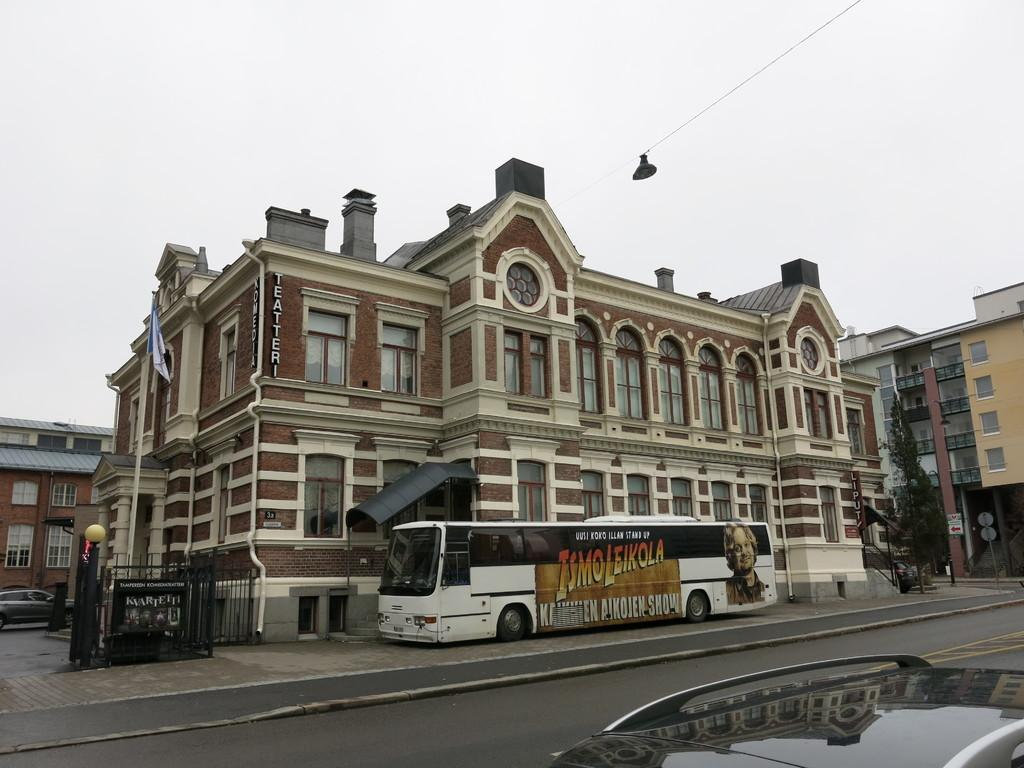What type of structure is present in the image? There is a building in the image. What mode of transportation can be seen in the image? There is a bus in the image. What part of the natural environment is visible in the background? The sky is visible in the background of the image. What type of balls are being used by the organization in the image? There is no mention of any balls or organizations in the image; it features a building and a bus. 